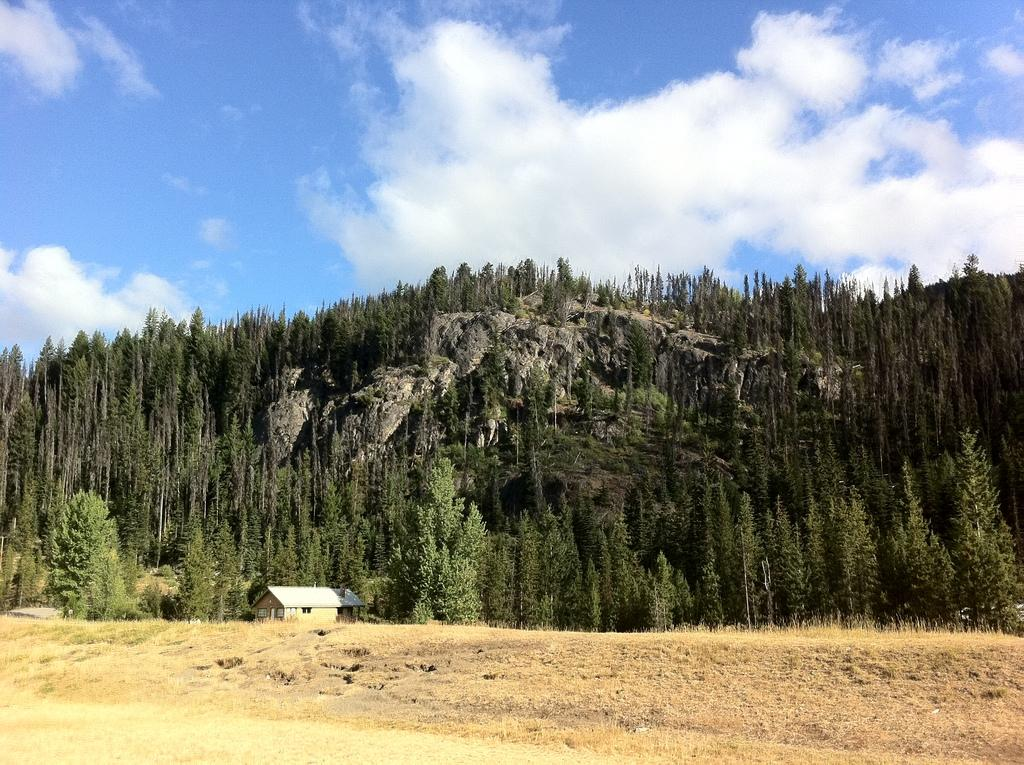What is located in the foreground of the image? There is a house, grass, and trees in the foreground of the image. What type of terrain is visible in the foreground of the image? The terrain in the foreground includes grass and trees. What geographical features can be seen in the background of the image? There are mountains visible in the image. What is the color of the sky in the image? The sky is blue and visible at the top of the image. Can you describe the possible location of the image based on the visible features? The image may have been taken near the mountains. What language is spoken by the trees in the image? Trees do not speak any language, so this question cannot be answered. What is the source of surprise in the image? There is no indication of surprise in the image, as it is a static representation of a scene. 